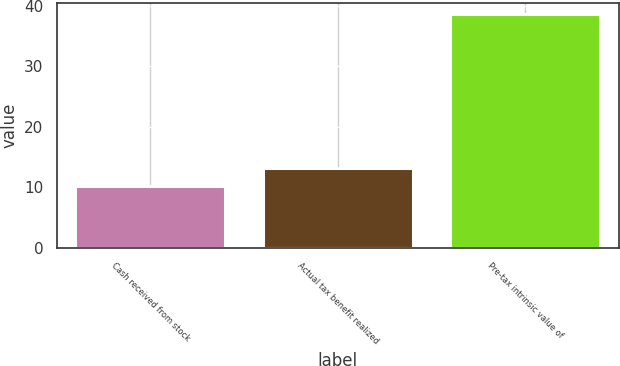Convert chart. <chart><loc_0><loc_0><loc_500><loc_500><bar_chart><fcel>Cash received from stock<fcel>Actual tax benefit realized<fcel>Pre-tax intrinsic value of<nl><fcel>10.3<fcel>13.13<fcel>38.6<nl></chart> 